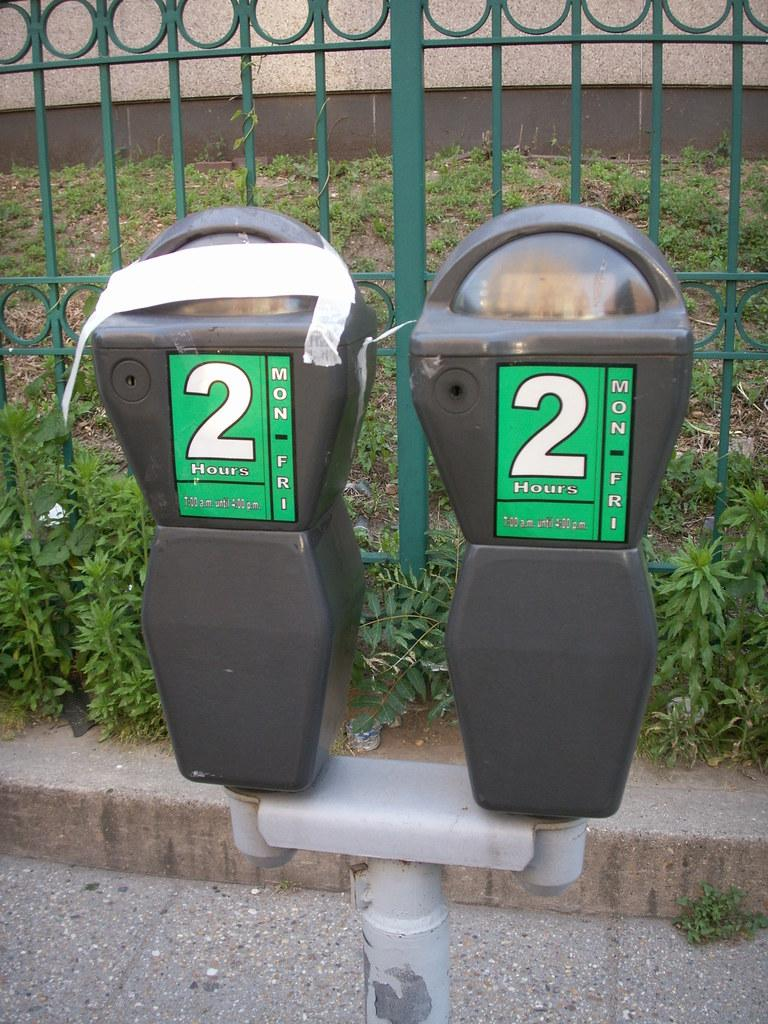<image>
Relay a brief, clear account of the picture shown. A duel parking meter with green stickers on the front and large white 2's. 